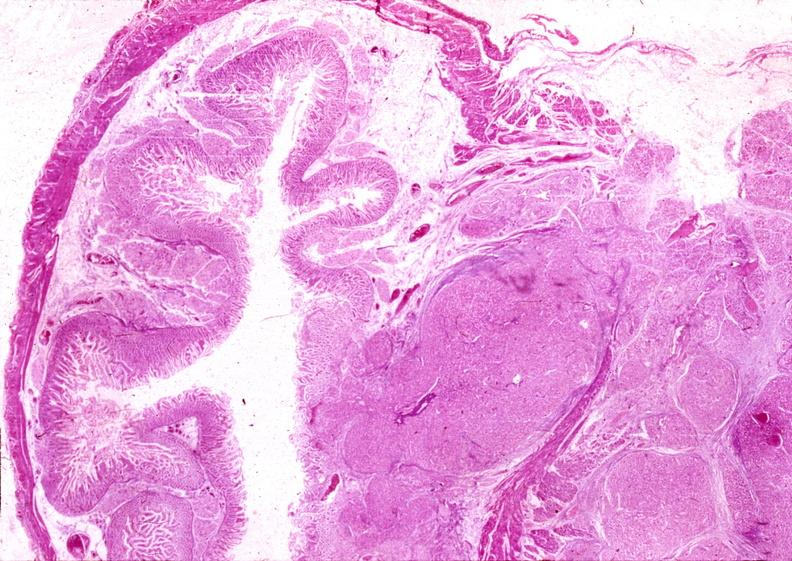where is this?
Answer the question using a single word or phrase. Pancreas 